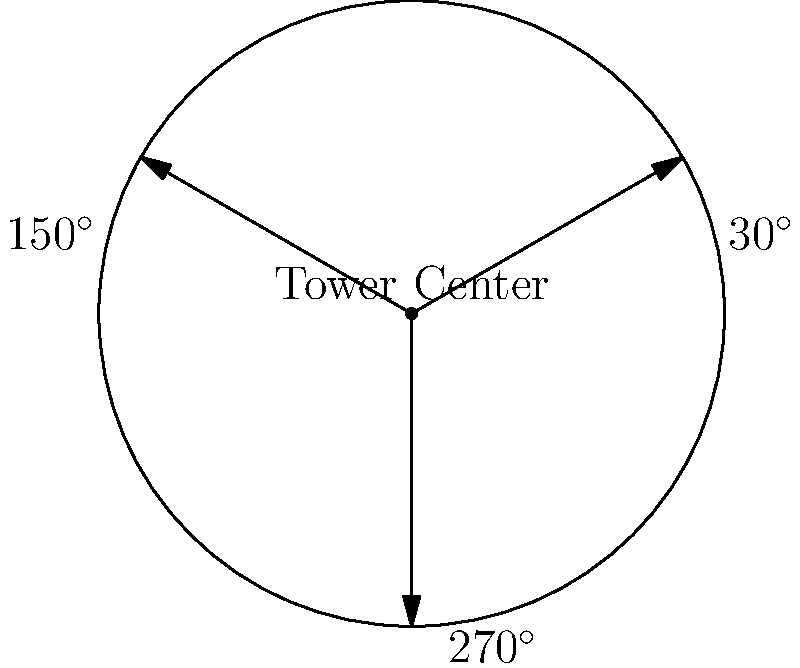A circular sniper tower has a radius of 50 meters. Three optimal sniper positions are located at polar coordinates $(50, 30^\circ)$, $(50, 150^\circ)$, and $(50, 270^\circ)$. What is the total area, in square meters, that these three snipers can effectively cover if each sniper has a circular coverage area with a radius of 200 meters? To solve this problem, we need to follow these steps:

1) First, we need to calculate the area of one sniper's coverage:
   Area of one circle = $\pi r^2 = \pi (200^2) = 40000\pi$ sq meters

2) Now, we need to calculate the total area of three circles:
   Total area = $3 \times 40000\pi = 120000\pi$ sq meters

3) However, these circles overlap. To find the overlapping areas, we need to use the formula for the area of intersection of two circles.

4) The distance between any two snipers can be calculated using the law of cosines:
   $d^2 = 50^2 + 50^2 - 2(50)(50)\cos(120^\circ) = 7500$
   $d = \sqrt{7500} \approx 86.6$ meters

5) The area of intersection of two circles with radius $r=200$ and distance between centers $d=86.6$ is:
   $A = 2r^2 \arccos(\frac{d}{2r}) - d\sqrt{r^2-(\frac{d}{2})^2}$
   $A \approx 54027.5$ sq meters

6) There are three such intersections, so the total overlapping area is:
   $3 \times 54027.5 = 162082.5$ sq meters

7) The effective coverage area is the total area minus the overlapping area:
   Effective area = $120000\pi - 162082.5 \approx 214777.5$ sq meters
Answer: $214777.5$ square meters 